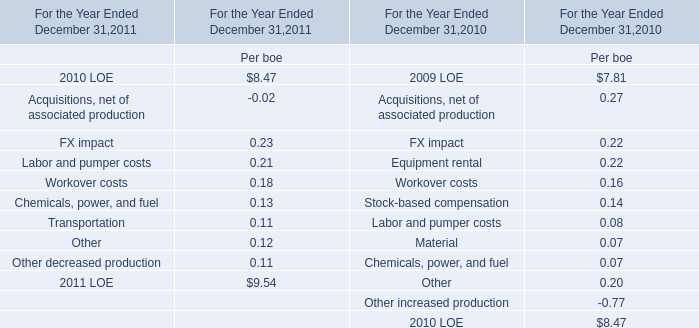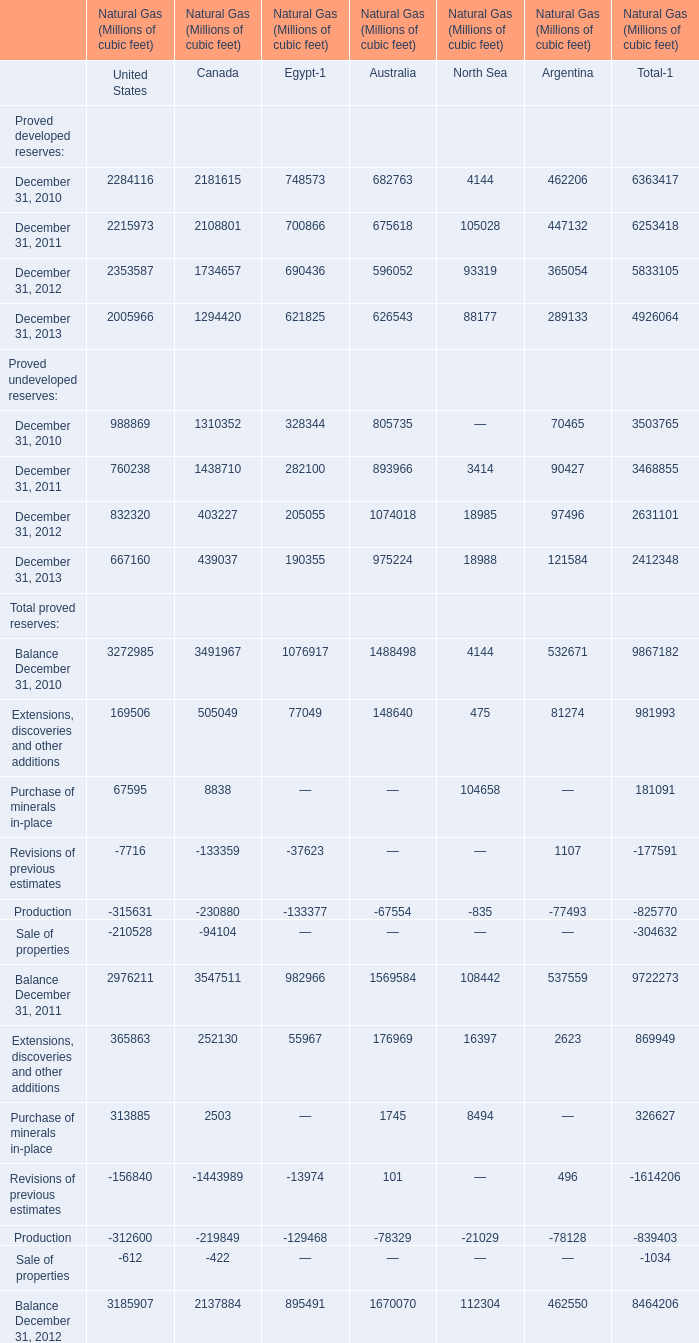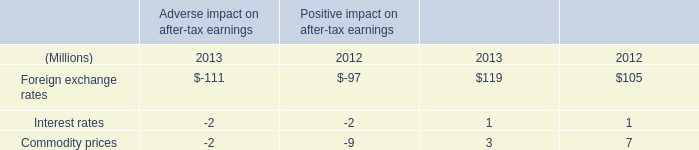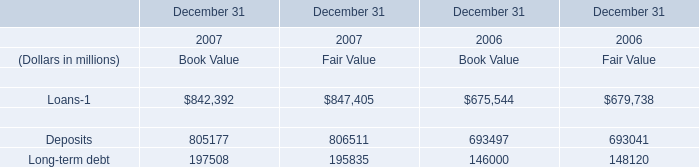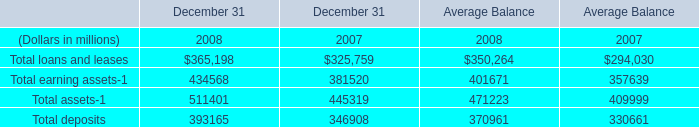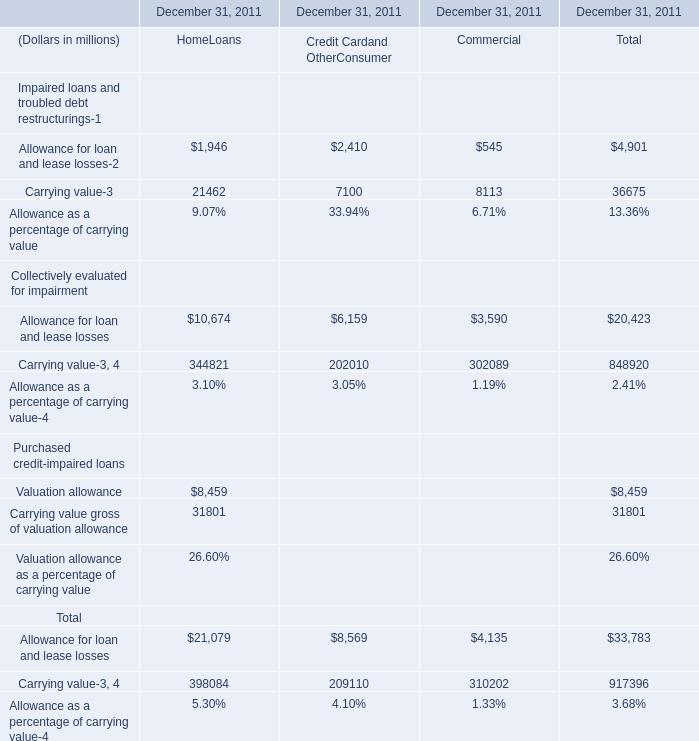What's the total amount of the Carrying value in table 2 in the years where Carrying value is greater than 21000? (in millions) 
Answer: 21462. 